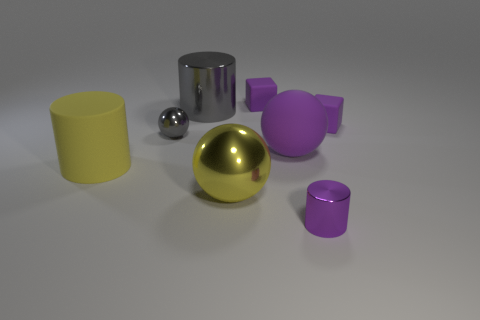Subtract all large metallic spheres. How many spheres are left? 2 Subtract all purple balls. How many balls are left? 2 Add 2 green cylinders. How many objects exist? 10 Subtract all spheres. How many objects are left? 5 Subtract 1 cylinders. How many cylinders are left? 2 Add 6 big brown rubber cylinders. How many big brown rubber cylinders exist? 6 Subtract 0 cyan balls. How many objects are left? 8 Subtract all green cubes. Subtract all brown spheres. How many cubes are left? 2 Subtract all small things. Subtract all large brown spheres. How many objects are left? 4 Add 6 purple cubes. How many purple cubes are left? 8 